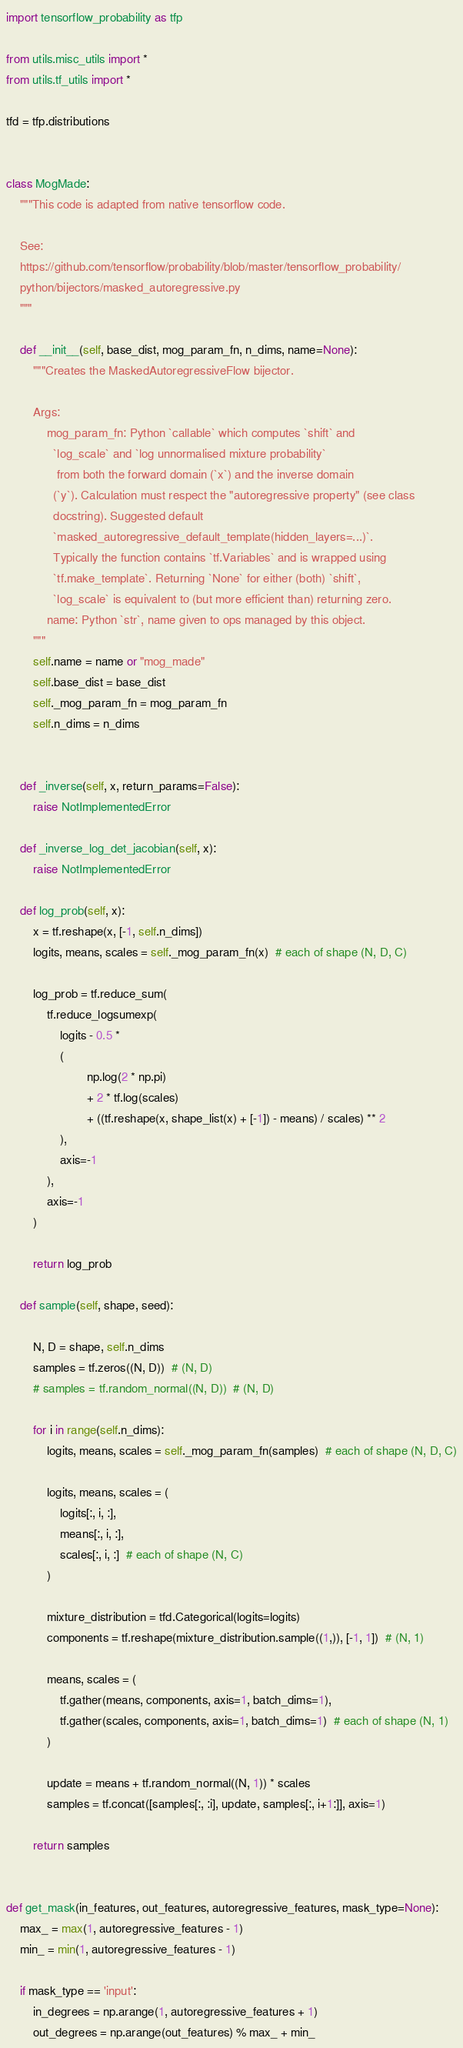Convert code to text. <code><loc_0><loc_0><loc_500><loc_500><_Python_>import tensorflow_probability as tfp

from utils.misc_utils import *
from utils.tf_utils import *

tfd = tfp.distributions


class MogMade:
    """This code is adapted from native tensorflow code.

    See:
    https://github.com/tensorflow/probability/blob/master/tensorflow_probability/
    python/bijectors/masked_autoregressive.py
    """

    def __init__(self, base_dist, mog_param_fn, n_dims, name=None):
        """Creates the MaskedAutoregressiveFlow bijector.

        Args:
            mog_param_fn: Python `callable` which computes `shift` and
              `log_scale` and `log unnormalised mixture probability`
               from both the forward domain (`x`) and the inverse domain
              (`y`). Calculation must respect the "autoregressive property" (see class
              docstring). Suggested default
              `masked_autoregressive_default_template(hidden_layers=...)`.
              Typically the function contains `tf.Variables` and is wrapped using
              `tf.make_template`. Returning `None` for either (both) `shift`,
              `log_scale` is equivalent to (but more efficient than) returning zero.
            name: Python `str`, name given to ops managed by this object.
        """
        self.name = name or "mog_made"
        self.base_dist = base_dist
        self._mog_param_fn = mog_param_fn
        self.n_dims = n_dims


    def _inverse(self, x, return_params=False):
        raise NotImplementedError

    def _inverse_log_det_jacobian(self, x):
        raise NotImplementedError

    def log_prob(self, x):
        x = tf.reshape(x, [-1, self.n_dims])
        logits, means, scales = self._mog_param_fn(x)  # each of shape (N, D, C)

        log_prob = tf.reduce_sum(
            tf.reduce_logsumexp(
                logits - 0.5 *
                (
                        np.log(2 * np.pi)
                        + 2 * tf.log(scales)
                        + ((tf.reshape(x, shape_list(x) + [-1]) - means) / scales) ** 2
                ),
                axis=-1
            ),
            axis=-1
        )

        return log_prob

    def sample(self, shape, seed):

        N, D = shape, self.n_dims
        samples = tf.zeros((N, D))  # (N, D)
        # samples = tf.random_normal((N, D))  # (N, D)

        for i in range(self.n_dims):
            logits, means, scales = self._mog_param_fn(samples)  # each of shape (N, D, C)

            logits, means, scales = (
                logits[:, i, :],
                means[:, i, :],
                scales[:, i, :]  # each of shape (N, C)
            )

            mixture_distribution = tfd.Categorical(logits=logits)
            components = tf.reshape(mixture_distribution.sample((1,)), [-1, 1])  # (N, 1)

            means, scales = (
                tf.gather(means, components, axis=1, batch_dims=1),
                tf.gather(scales, components, axis=1, batch_dims=1)  # each of shape (N, 1)
            )

            update = means + tf.random_normal((N, 1)) * scales
            samples = tf.concat([samples[:, :i], update, samples[:, i+1:]], axis=1)

        return samples


def get_mask(in_features, out_features, autoregressive_features, mask_type=None):
    max_ = max(1, autoregressive_features - 1)
    min_ = min(1, autoregressive_features - 1)

    if mask_type == 'input':
        in_degrees = np.arange(1, autoregressive_features + 1)
        out_degrees = np.arange(out_features) % max_ + min_</code> 